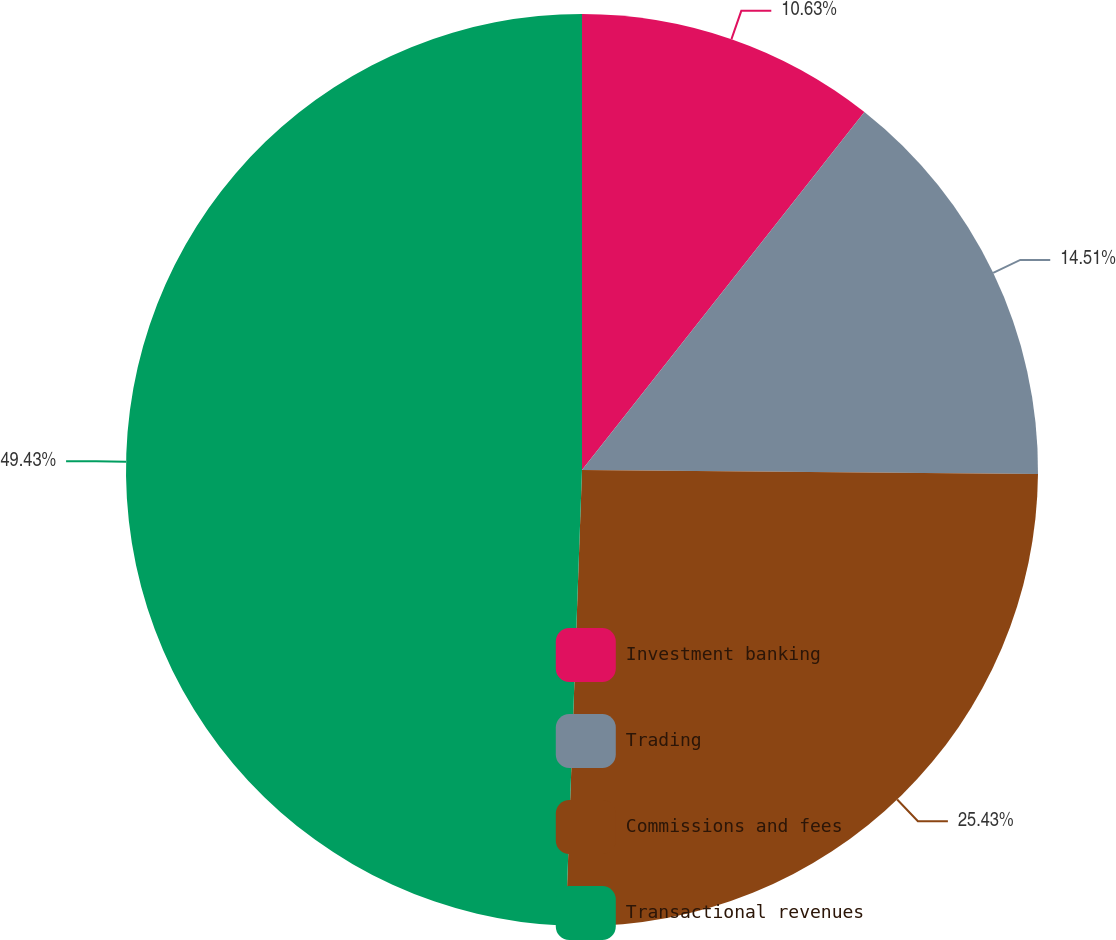Convert chart to OTSL. <chart><loc_0><loc_0><loc_500><loc_500><pie_chart><fcel>Investment banking<fcel>Trading<fcel>Commissions and fees<fcel>Transactional revenues<nl><fcel>10.63%<fcel>14.51%<fcel>25.43%<fcel>49.43%<nl></chart> 